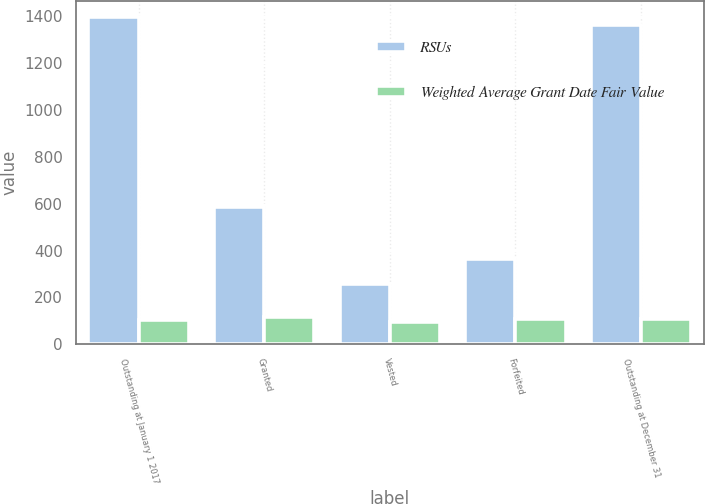Convert chart. <chart><loc_0><loc_0><loc_500><loc_500><stacked_bar_chart><ecel><fcel>Outstanding at January 1 2017<fcel>Granted<fcel>Vested<fcel>Forfeited<fcel>Outstanding at December 31<nl><fcel>RSUs<fcel>1394<fcel>586<fcel>256<fcel>363<fcel>1361<nl><fcel>Weighted Average Grant Date Fair Value<fcel>102.04<fcel>115.77<fcel>97.12<fcel>107.02<fcel>107.56<nl></chart> 